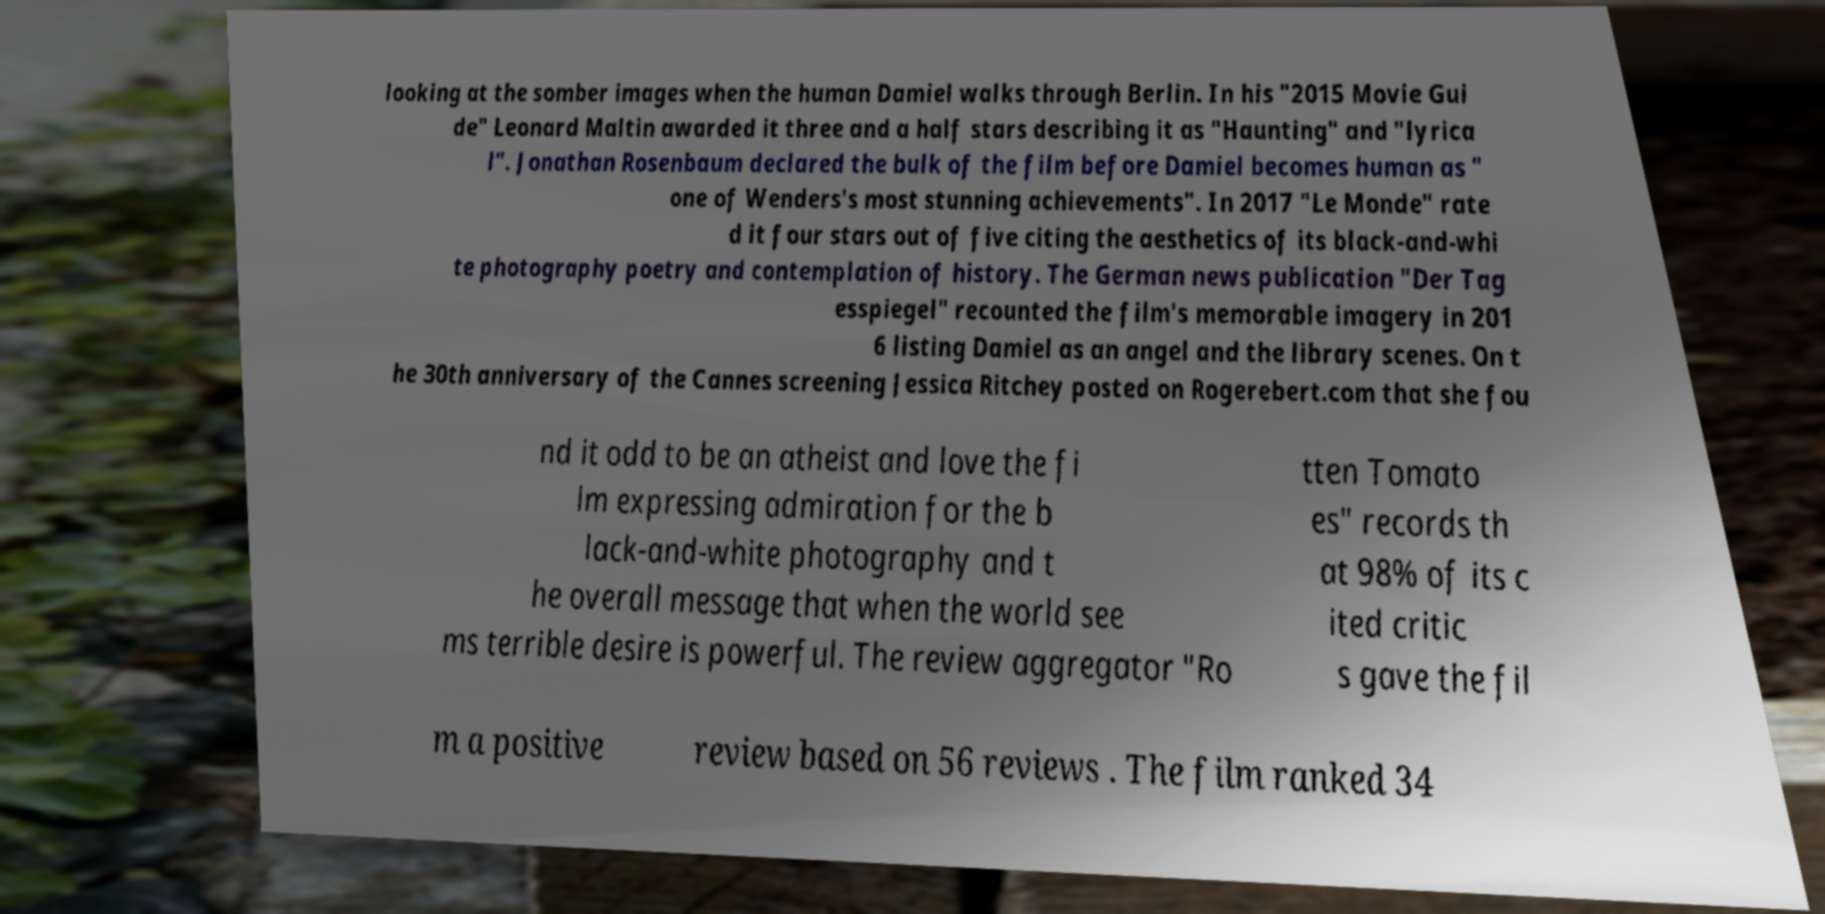Could you extract and type out the text from this image? looking at the somber images when the human Damiel walks through Berlin. In his "2015 Movie Gui de" Leonard Maltin awarded it three and a half stars describing it as "Haunting" and "lyrica l". Jonathan Rosenbaum declared the bulk of the film before Damiel becomes human as " one of Wenders's most stunning achievements". In 2017 "Le Monde" rate d it four stars out of five citing the aesthetics of its black-and-whi te photography poetry and contemplation of history. The German news publication "Der Tag esspiegel" recounted the film's memorable imagery in 201 6 listing Damiel as an angel and the library scenes. On t he 30th anniversary of the Cannes screening Jessica Ritchey posted on Rogerebert.com that she fou nd it odd to be an atheist and love the fi lm expressing admiration for the b lack-and-white photography and t he overall message that when the world see ms terrible desire is powerful. The review aggregator "Ro tten Tomato es" records th at 98% of its c ited critic s gave the fil m a positive review based on 56 reviews . The film ranked 34 